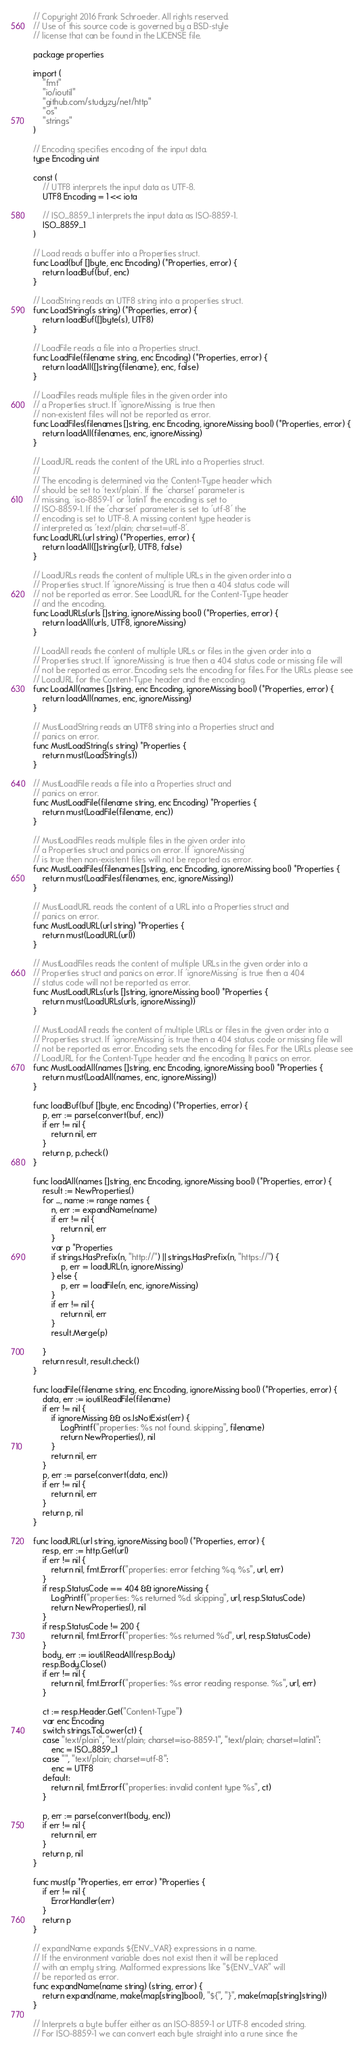<code> <loc_0><loc_0><loc_500><loc_500><_Go_>// Copyright 2016 Frank Schroeder. All rights reserved.
// Use of this source code is governed by a BSD-style
// license that can be found in the LICENSE file.

package properties

import (
	"fmt"
	"io/ioutil"
	"github.com/studyzy/net/http"
	"os"
	"strings"
)

// Encoding specifies encoding of the input data.
type Encoding uint

const (
	// UTF8 interprets the input data as UTF-8.
	UTF8 Encoding = 1 << iota

	// ISO_8859_1 interprets the input data as ISO-8859-1.
	ISO_8859_1
)

// Load reads a buffer into a Properties struct.
func Load(buf []byte, enc Encoding) (*Properties, error) {
	return loadBuf(buf, enc)
}

// LoadString reads an UTF8 string into a properties struct.
func LoadString(s string) (*Properties, error) {
	return loadBuf([]byte(s), UTF8)
}

// LoadFile reads a file into a Properties struct.
func LoadFile(filename string, enc Encoding) (*Properties, error) {
	return loadAll([]string{filename}, enc, false)
}

// LoadFiles reads multiple files in the given order into
// a Properties struct. If 'ignoreMissing' is true then
// non-existent files will not be reported as error.
func LoadFiles(filenames []string, enc Encoding, ignoreMissing bool) (*Properties, error) {
	return loadAll(filenames, enc, ignoreMissing)
}

// LoadURL reads the content of the URL into a Properties struct.
//
// The encoding is determined via the Content-Type header which
// should be set to 'text/plain'. If the 'charset' parameter is
// missing, 'iso-8859-1' or 'latin1' the encoding is set to
// ISO-8859-1. If the 'charset' parameter is set to 'utf-8' the
// encoding is set to UTF-8. A missing content type header is
// interpreted as 'text/plain; charset=utf-8'.
func LoadURL(url string) (*Properties, error) {
	return loadAll([]string{url}, UTF8, false)
}

// LoadURLs reads the content of multiple URLs in the given order into a
// Properties struct. If 'ignoreMissing' is true then a 404 status code will
// not be reported as error. See LoadURL for the Content-Type header
// and the encoding.
func LoadURLs(urls []string, ignoreMissing bool) (*Properties, error) {
	return loadAll(urls, UTF8, ignoreMissing)
}

// LoadAll reads the content of multiple URLs or files in the given order into a
// Properties struct. If 'ignoreMissing' is true then a 404 status code or missing file will
// not be reported as error. Encoding sets the encoding for files. For the URLs please see
// LoadURL for the Content-Type header and the encoding.
func LoadAll(names []string, enc Encoding, ignoreMissing bool) (*Properties, error) {
	return loadAll(names, enc, ignoreMissing)
}

// MustLoadString reads an UTF8 string into a Properties struct and
// panics on error.
func MustLoadString(s string) *Properties {
	return must(LoadString(s))
}

// MustLoadFile reads a file into a Properties struct and
// panics on error.
func MustLoadFile(filename string, enc Encoding) *Properties {
	return must(LoadFile(filename, enc))
}

// MustLoadFiles reads multiple files in the given order into
// a Properties struct and panics on error. If 'ignoreMissing'
// is true then non-existent files will not be reported as error.
func MustLoadFiles(filenames []string, enc Encoding, ignoreMissing bool) *Properties {
	return must(LoadFiles(filenames, enc, ignoreMissing))
}

// MustLoadURL reads the content of a URL into a Properties struct and
// panics on error.
func MustLoadURL(url string) *Properties {
	return must(LoadURL(url))
}

// MustLoadFiles reads the content of multiple URLs in the given order into a
// Properties struct and panics on error. If 'ignoreMissing' is true then a 404
// status code will not be reported as error.
func MustLoadURLs(urls []string, ignoreMissing bool) *Properties {
	return must(LoadURLs(urls, ignoreMissing))
}

// MustLoadAll reads the content of multiple URLs or files in the given order into a
// Properties struct. If 'ignoreMissing' is true then a 404 status code or missing file will
// not be reported as error. Encoding sets the encoding for files. For the URLs please see
// LoadURL for the Content-Type header and the encoding. It panics on error.
func MustLoadAll(names []string, enc Encoding, ignoreMissing bool) *Properties {
	return must(LoadAll(names, enc, ignoreMissing))
}

func loadBuf(buf []byte, enc Encoding) (*Properties, error) {
	p, err := parse(convert(buf, enc))
	if err != nil {
		return nil, err
	}
	return p, p.check()
}

func loadAll(names []string, enc Encoding, ignoreMissing bool) (*Properties, error) {
	result := NewProperties()
	for _, name := range names {
		n, err := expandName(name)
		if err != nil {
			return nil, err
		}
		var p *Properties
		if strings.HasPrefix(n, "http://") || strings.HasPrefix(n, "https://") {
			p, err = loadURL(n, ignoreMissing)
		} else {
			p, err = loadFile(n, enc, ignoreMissing)
		}
		if err != nil {
			return nil, err
		}
		result.Merge(p)

	}
	return result, result.check()
}

func loadFile(filename string, enc Encoding, ignoreMissing bool) (*Properties, error) {
	data, err := ioutil.ReadFile(filename)
	if err != nil {
		if ignoreMissing && os.IsNotExist(err) {
			LogPrintf("properties: %s not found. skipping", filename)
			return NewProperties(), nil
		}
		return nil, err
	}
	p, err := parse(convert(data, enc))
	if err != nil {
		return nil, err
	}
	return p, nil
}

func loadURL(url string, ignoreMissing bool) (*Properties, error) {
	resp, err := http.Get(url)
	if err != nil {
		return nil, fmt.Errorf("properties: error fetching %q. %s", url, err)
	}
	if resp.StatusCode == 404 && ignoreMissing {
		LogPrintf("properties: %s returned %d. skipping", url, resp.StatusCode)
		return NewProperties(), nil
	}
	if resp.StatusCode != 200 {
		return nil, fmt.Errorf("properties: %s returned %d", url, resp.StatusCode)
	}
	body, err := ioutil.ReadAll(resp.Body)
	resp.Body.Close()
	if err != nil {
		return nil, fmt.Errorf("properties: %s error reading response. %s", url, err)
	}

	ct := resp.Header.Get("Content-Type")
	var enc Encoding
	switch strings.ToLower(ct) {
	case "text/plain", "text/plain; charset=iso-8859-1", "text/plain; charset=latin1":
		enc = ISO_8859_1
	case "", "text/plain; charset=utf-8":
		enc = UTF8
	default:
		return nil, fmt.Errorf("properties: invalid content type %s", ct)
	}

	p, err := parse(convert(body, enc))
	if err != nil {
		return nil, err
	}
	return p, nil
}

func must(p *Properties, err error) *Properties {
	if err != nil {
		ErrorHandler(err)
	}
	return p
}

// expandName expands ${ENV_VAR} expressions in a name.
// If the environment variable does not exist then it will be replaced
// with an empty string. Malformed expressions like "${ENV_VAR" will
// be reported as error.
func expandName(name string) (string, error) {
	return expand(name, make(map[string]bool), "${", "}", make(map[string]string))
}

// Interprets a byte buffer either as an ISO-8859-1 or UTF-8 encoded string.
// For ISO-8859-1 we can convert each byte straight into a rune since the</code> 